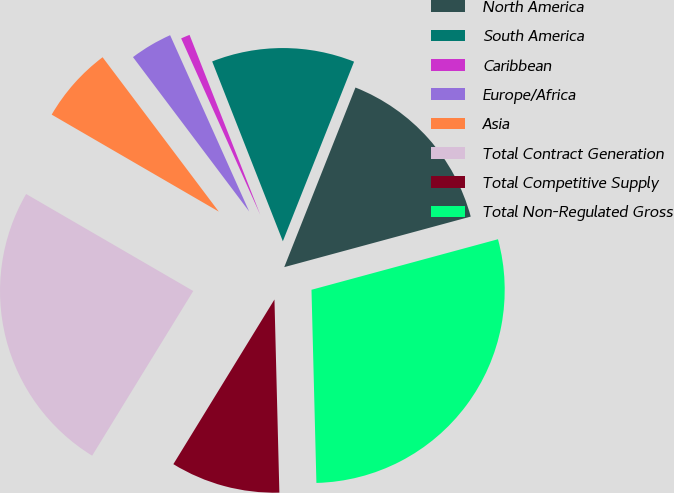<chart> <loc_0><loc_0><loc_500><loc_500><pie_chart><fcel>North America<fcel>South America<fcel>Caribbean<fcel>Europe/Africa<fcel>Asia<fcel>Total Contract Generation<fcel>Total Competitive Supply<fcel>Total Non-Regulated Gross<nl><fcel>14.78%<fcel>11.97%<fcel>0.75%<fcel>3.56%<fcel>6.36%<fcel>24.61%<fcel>9.17%<fcel>28.81%<nl></chart> 